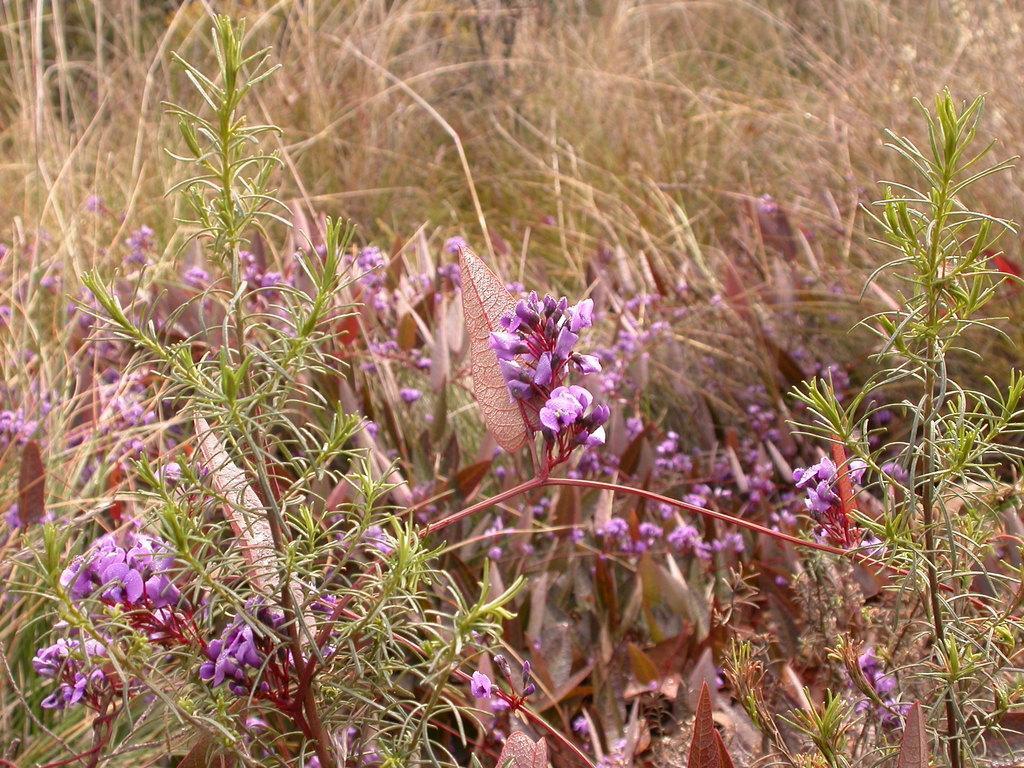Can you describe this image briefly? In this image there are plants and we can see flowers. In the background there is grass. 